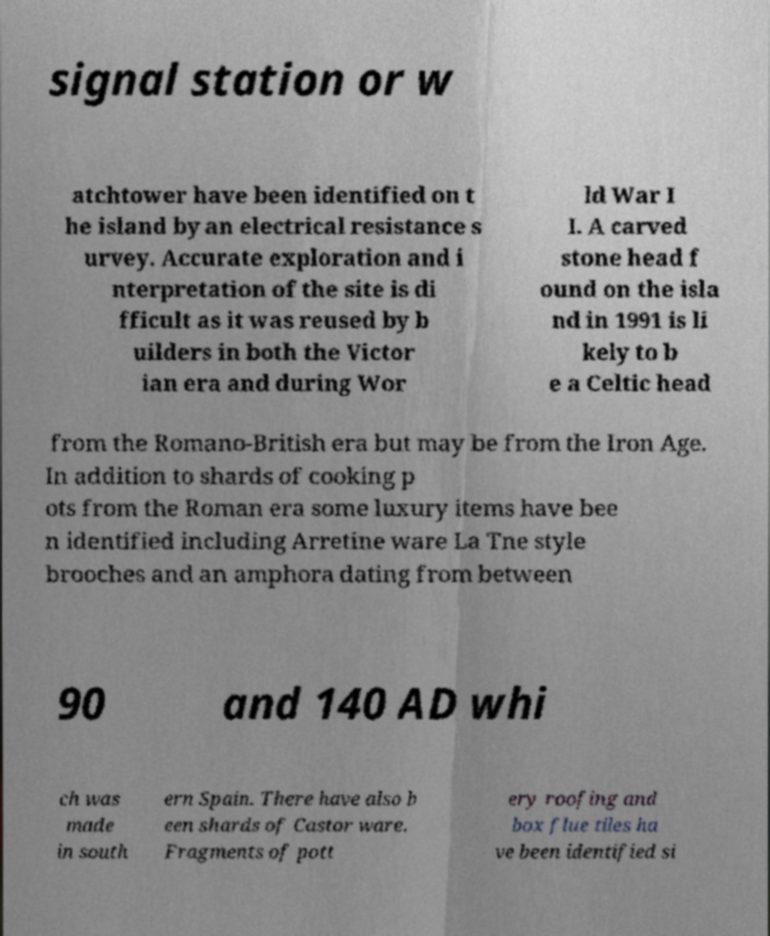For documentation purposes, I need the text within this image transcribed. Could you provide that? signal station or w atchtower have been identified on t he island by an electrical resistance s urvey. Accurate exploration and i nterpretation of the site is di fficult as it was reused by b uilders in both the Victor ian era and during Wor ld War I I. A carved stone head f ound on the isla nd in 1991 is li kely to b e a Celtic head from the Romano-British era but may be from the Iron Age. In addition to shards of cooking p ots from the Roman era some luxury items have bee n identified including Arretine ware La Tne style brooches and an amphora dating from between 90 and 140 AD whi ch was made in south ern Spain. There have also b een shards of Castor ware. Fragments of pott ery roofing and box flue tiles ha ve been identified si 